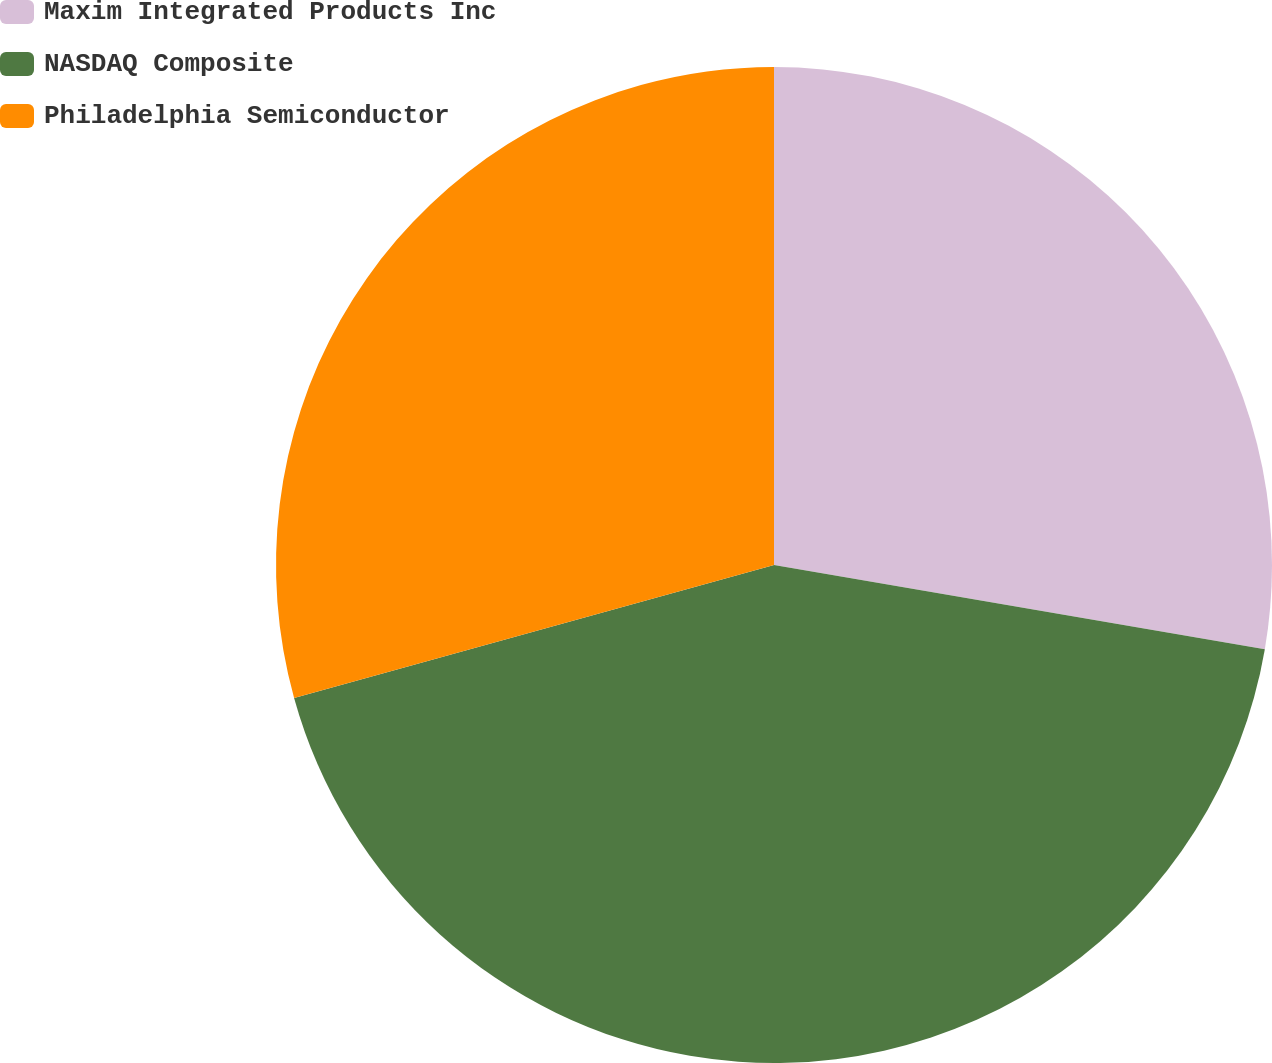Convert chart. <chart><loc_0><loc_0><loc_500><loc_500><pie_chart><fcel>Maxim Integrated Products Inc<fcel>NASDAQ Composite<fcel>Philadelphia Semiconductor<nl><fcel>27.7%<fcel>42.99%<fcel>29.3%<nl></chart> 